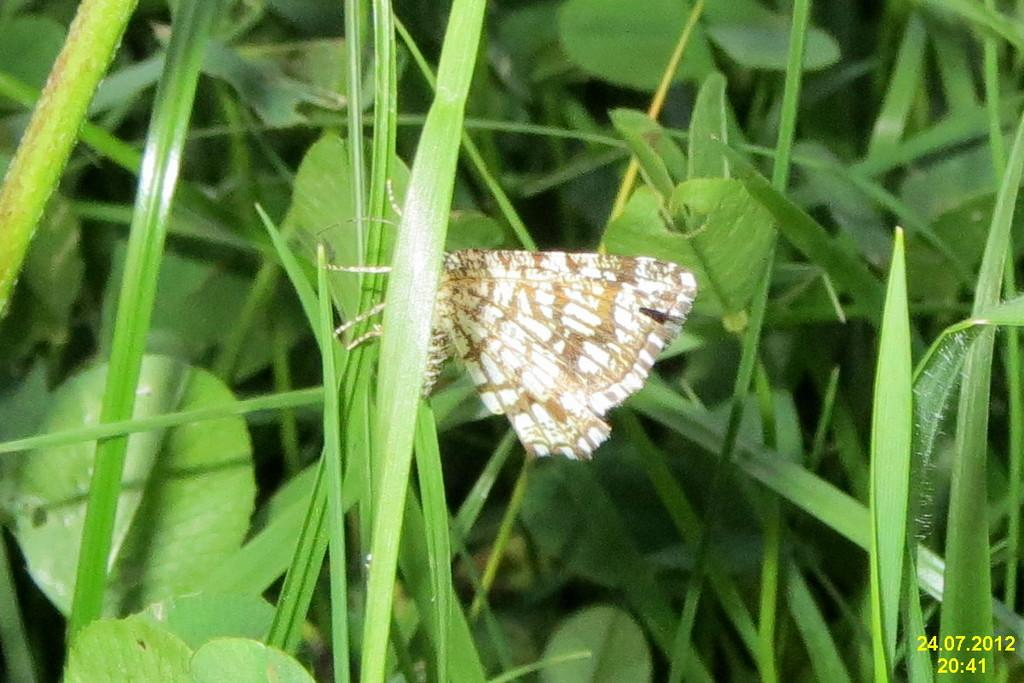What type of vegetation is present in the image? There is grass in the image. What can be seen on the grass? There is a butterfly on the grass. What type of polish is the butterfly using to clean its wings in the image? There is no polish present in the image, and butterflies do not use polish to clean their wings. 